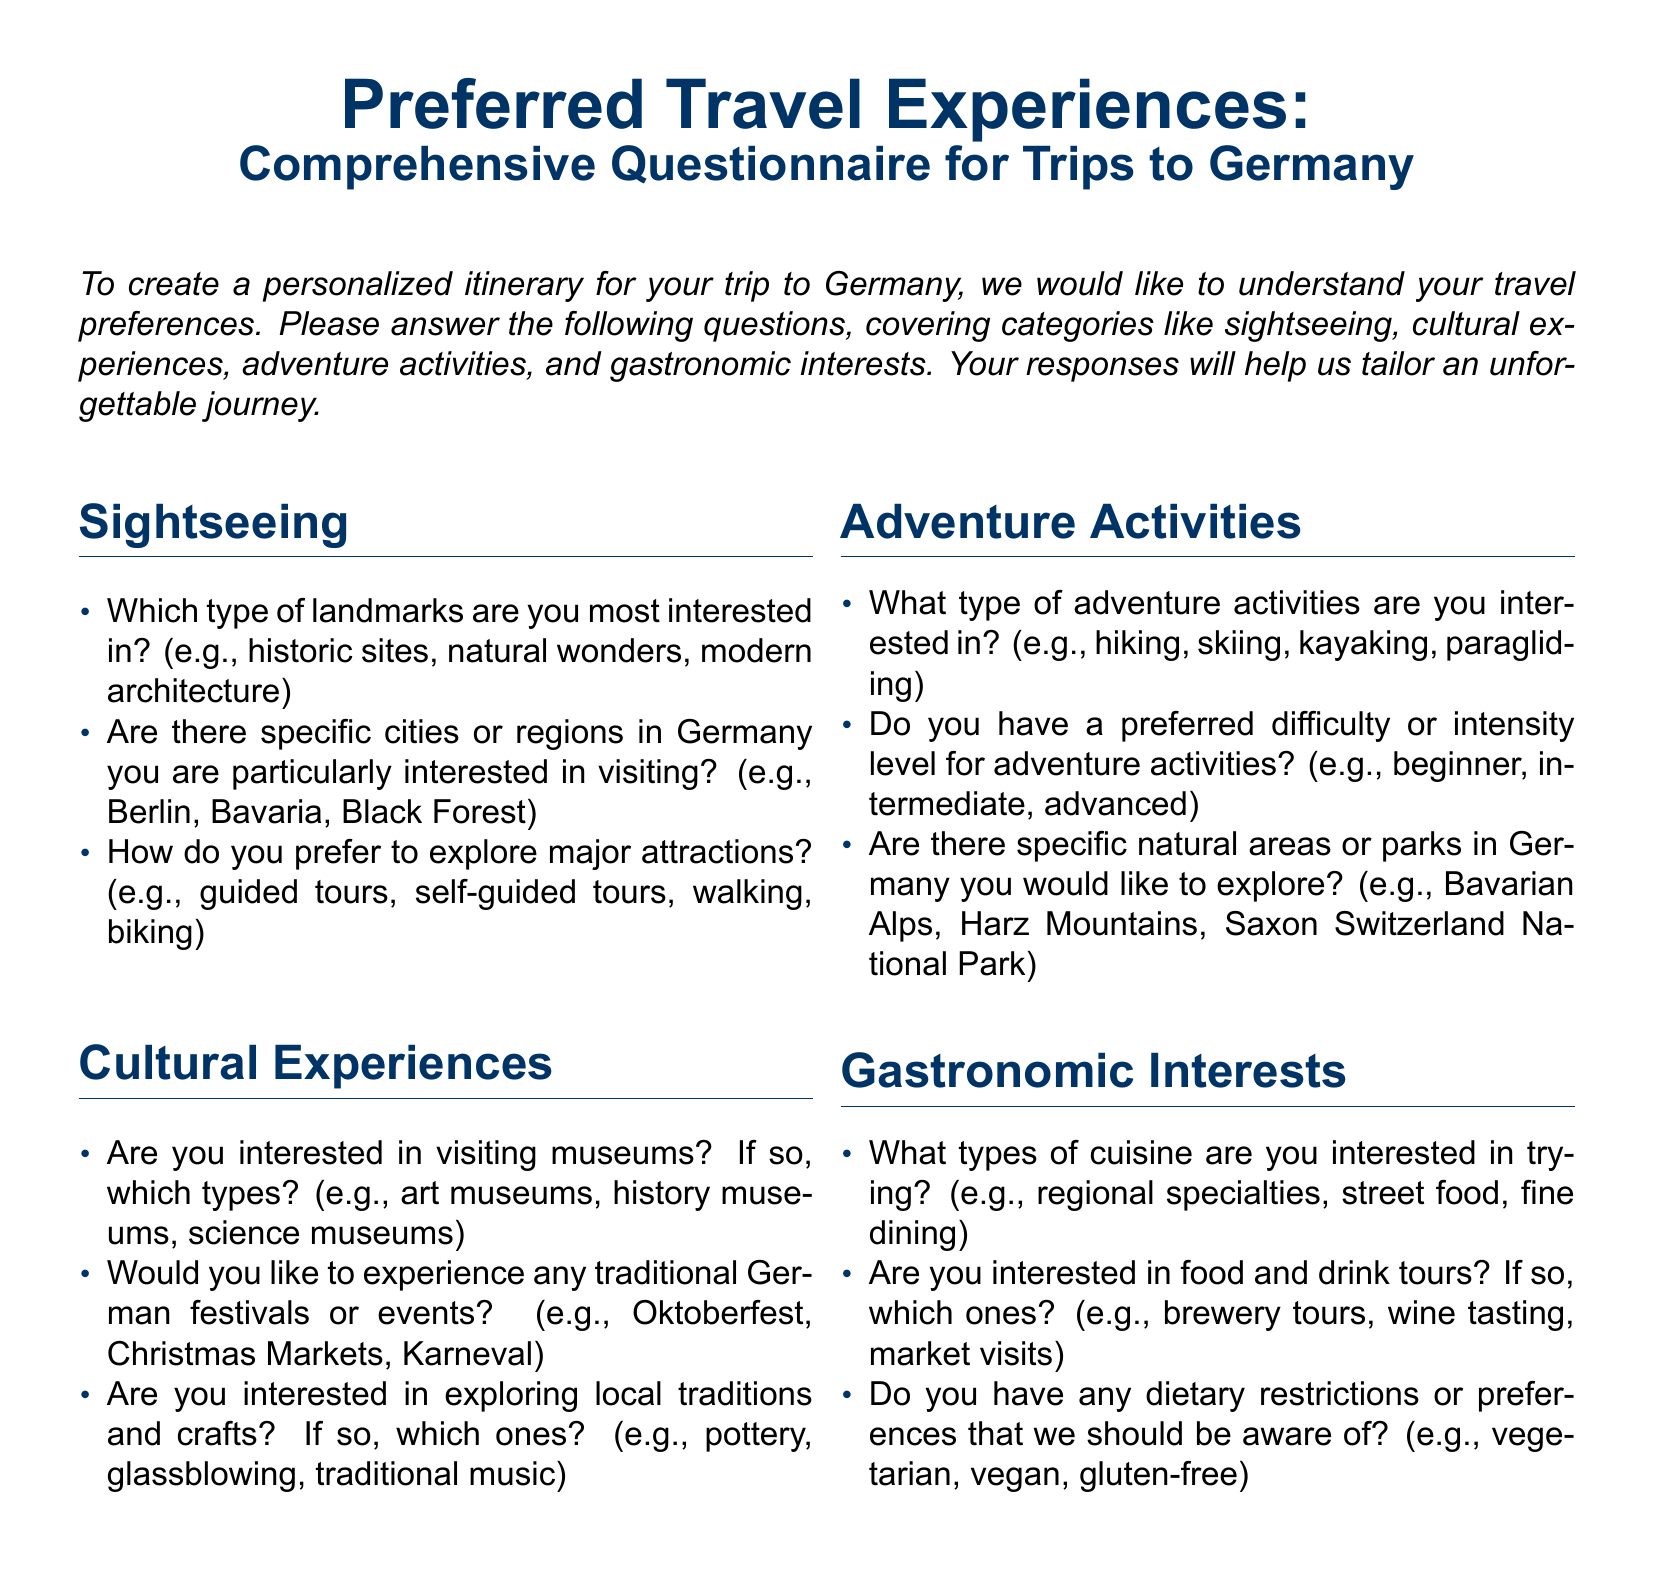What is the main purpose of this questionnaire? The main purpose is to understand clients' travel preferences to create personalized itineraries for trips to Germany.
Answer: Understand travel preferences How many sections are in this questionnaire? The document contains four sections: Sightseeing, Cultural Experiences, Adventure Activities, and Gastronomic Interests.
Answer: Four sections What type of landmarks does the questionnaire ask about? It inquires about landmarks such as historic sites, natural wonders, and modern architecture.
Answer: Historic sites, natural wonders, modern architecture Which traditional German event is mentioned in the Cultural Experiences section? Oktoberfest is listed as an example of a traditional German event that clients may be interested in experiencing.
Answer: Oktoberfest What adventure activity does the questionnaire suggest clients might be interested in? The questionnaire suggests activities like hiking, skiing, kayaking, and paragliding as possible interests for clients.
Answer: Hiking, skiing, kayaking, paragliding What dietary preferences does the Gastronomic Interests section inquire about? It asks about dietary restrictions or preferences such as vegetarian, vegan, or gluten-free.
Answer: Vegetarian, vegan, gluten-free What type of cuisine does the questionnaire ask about trying? It asks clients about types of cuisine, which include regional specialties, street food, and fine dining.
Answer: Regional specialties, street food, fine dining Is the questionnaire asking for information about specific cities in Germany? Yes, it asks if there are specific cities or regions in Germany that clients are particularly interested in visiting.
Answer: Yes What kind of tours does the Gastronomic Interests section mention? It mentions food and drink tours, including brewery tours, wine tasting, and market visits.
Answer: Brewery tours, wine tasting, market visits 